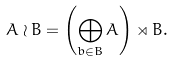<formula> <loc_0><loc_0><loc_500><loc_500>A \wr B = \left ( \bigoplus _ { b \in B } A \right ) \rtimes B .</formula> 